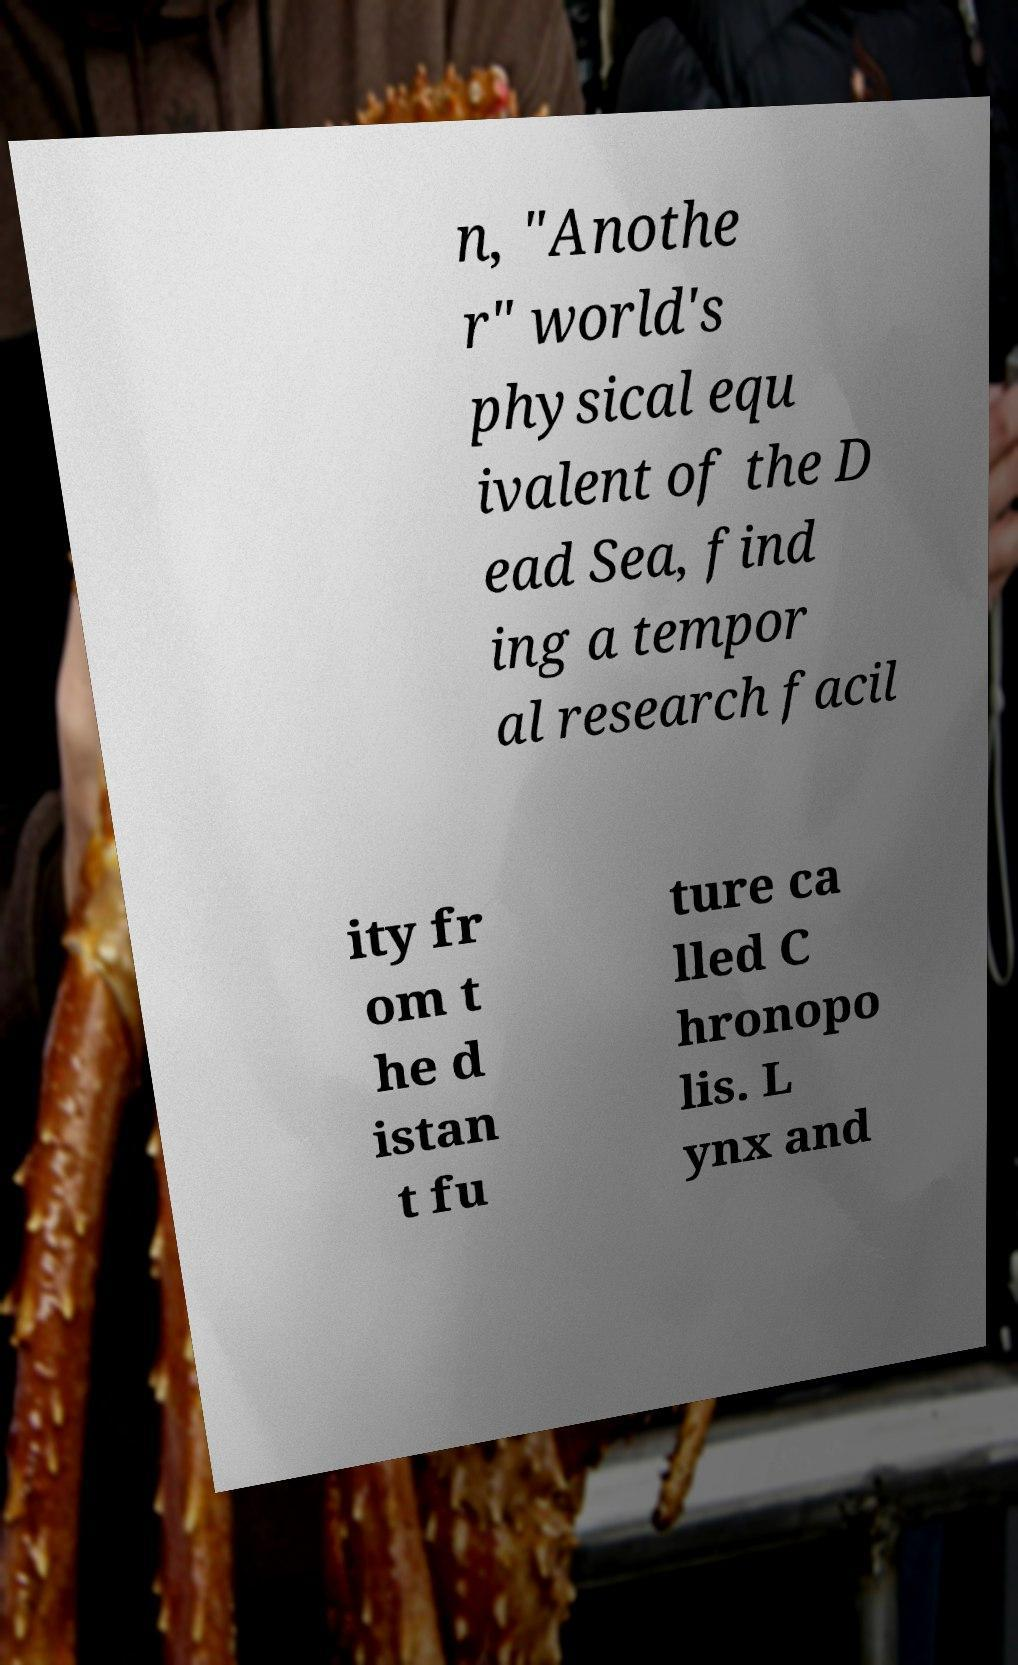I need the written content from this picture converted into text. Can you do that? n, "Anothe r" world's physical equ ivalent of the D ead Sea, find ing a tempor al research facil ity fr om t he d istan t fu ture ca lled C hronopo lis. L ynx and 